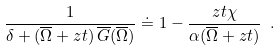<formula> <loc_0><loc_0><loc_500><loc_500>\frac { 1 } { \delta + ( \overline { \Omega } + z t ) \, \overline { G } ( \overline { \Omega } ) } \doteq 1 - \frac { z t \chi } { \alpha ( \overline { \Omega } + z t ) } \ .</formula> 